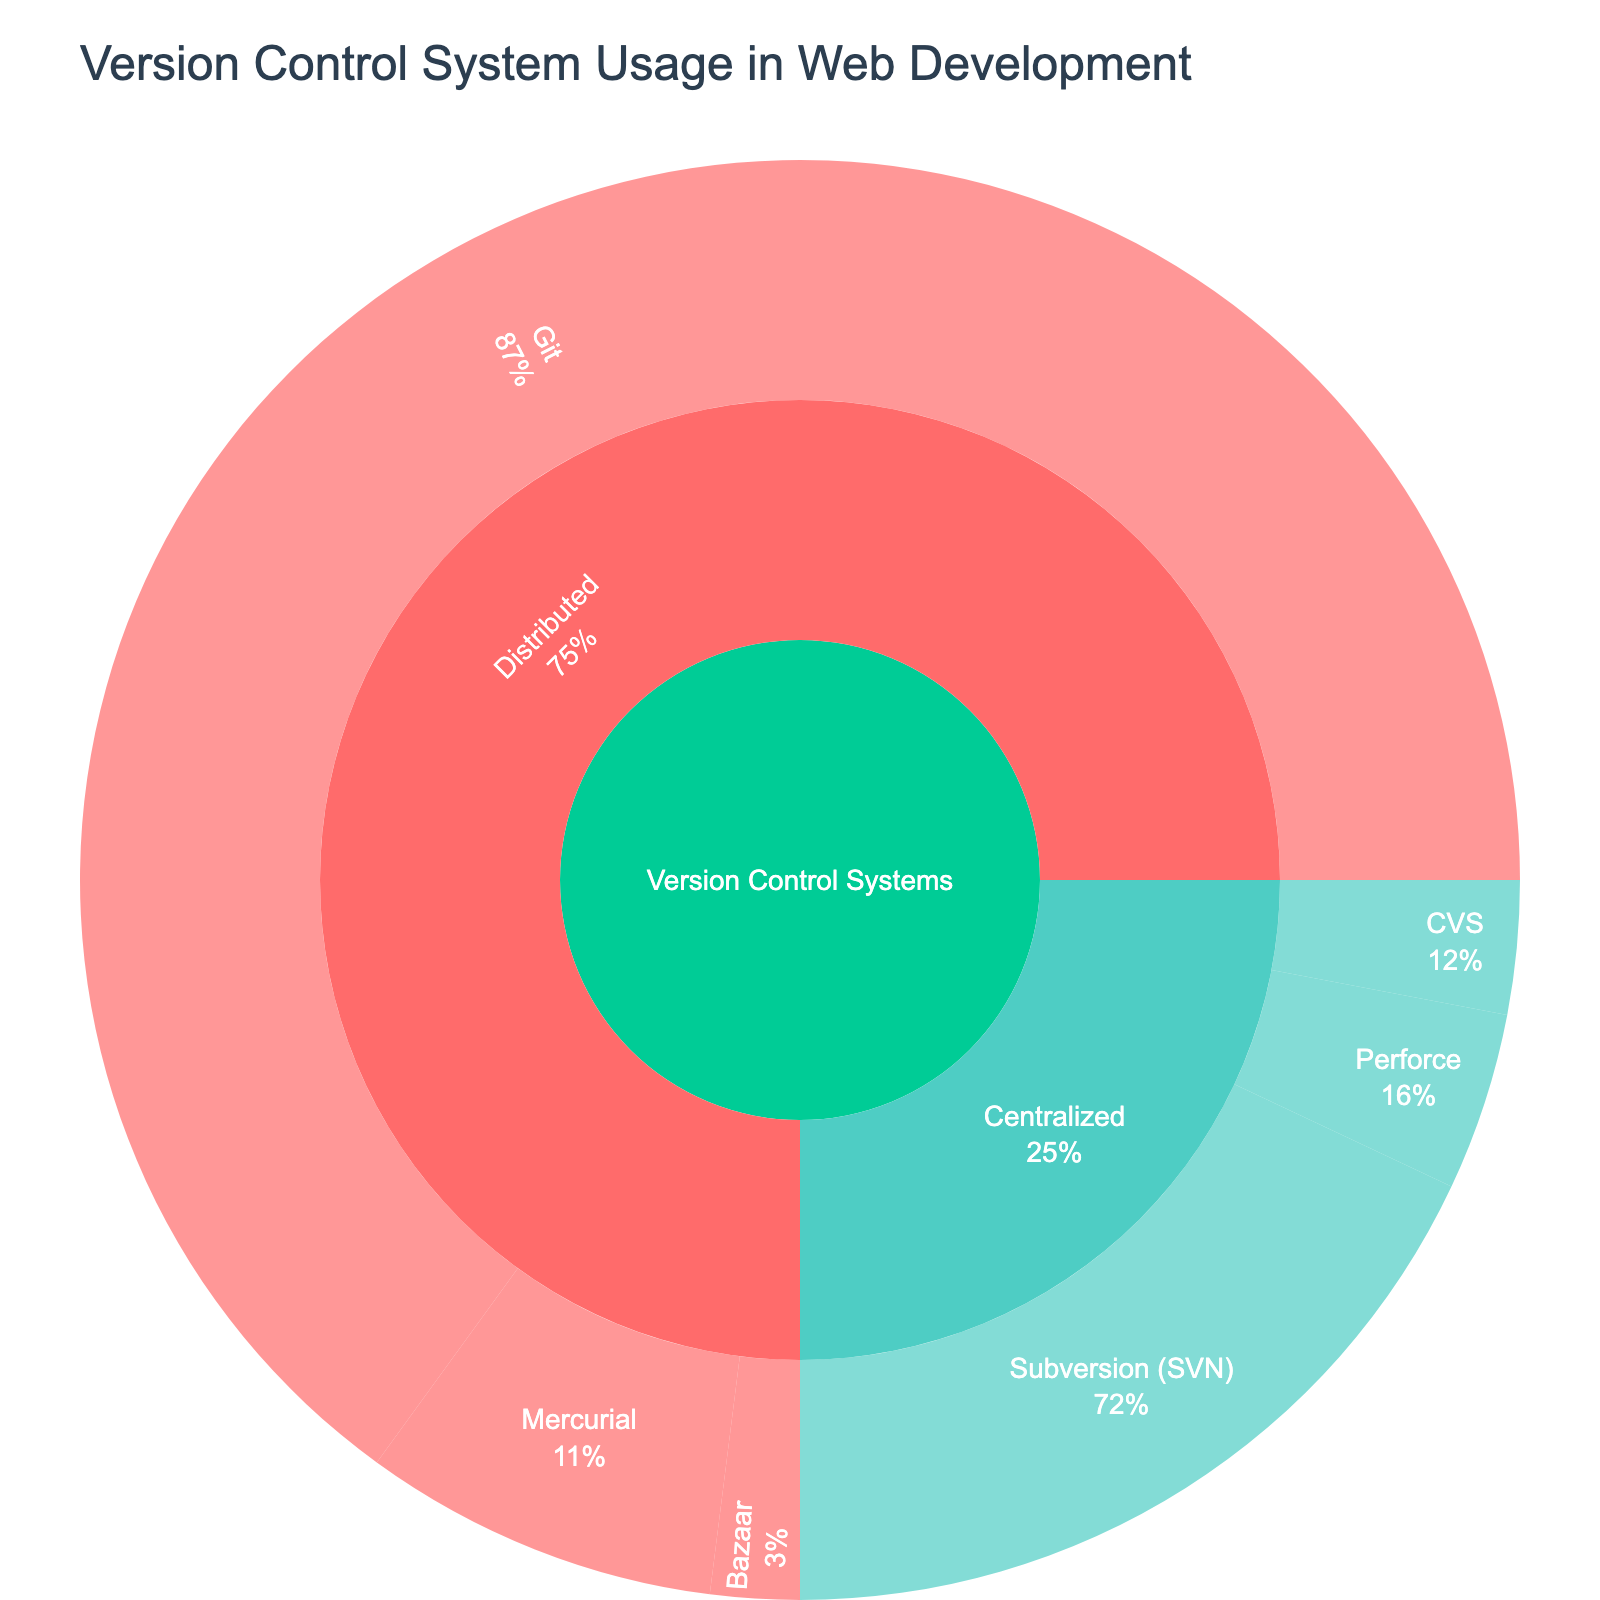What is the title of the sunburst plot? The title of the plot is typically found at the top of the figure and provides a summary of the content.
Answer: Version Control System Usage in Web Development Which category has the highest usage percentage in web development? To find this, observe the largest portion of the sunburst plot. Compare the sizes visually.
Answer: Distributed What is the usage percentage of Git within Distributed systems? Locate the "Git" label under "Distributed" in the sunburst plot and read the percentage value displayed.
Answer: 65% How does the usage of Subversion (SVN) compare to Mercurial? Look at the sizes and percentages of Subversion (SVN) and Mercurial. Compare their values directly.
Answer: Subversion (SVN) has a higher usage (18%) compared to Mercurial (8%) What is the combined usage percentage of Perforce and CVS? Find both Perforce and CVS values, then add them together to get the combined total. Perforce (4%) + CVS (3%) = 7%.
Answer: 7% Which version control system is the least used? Look for the smallest segment in the sunburst plot. Identify the label and percentage.
Answer: Bazaar Within Centralized systems, which version control system has the highest usage? Look for the subcategory "Centralized", then identify which system has the largest segment.
Answer: Subversion (SVN) What percentage of the Version Control Systems category does Distributed systems represent? Locate the "Distributed" segment within the entire "Version Control Systems" category and read its percentage.
Answer: 75% Compare the total number of usage between Distributed and Centralized systems. Sum the usages of all systems under Distributed and do the same for Centralized. Distributed (65+8+2=75), Centralized (18+4+3=25). Compare the sums.
Answer: Distributed systems have higher total usage (75 vs. 25) How many different systems are represented in the plot? Count all the unique system labels in the sunburst plot across all categories and subcategories.
Answer: 6 